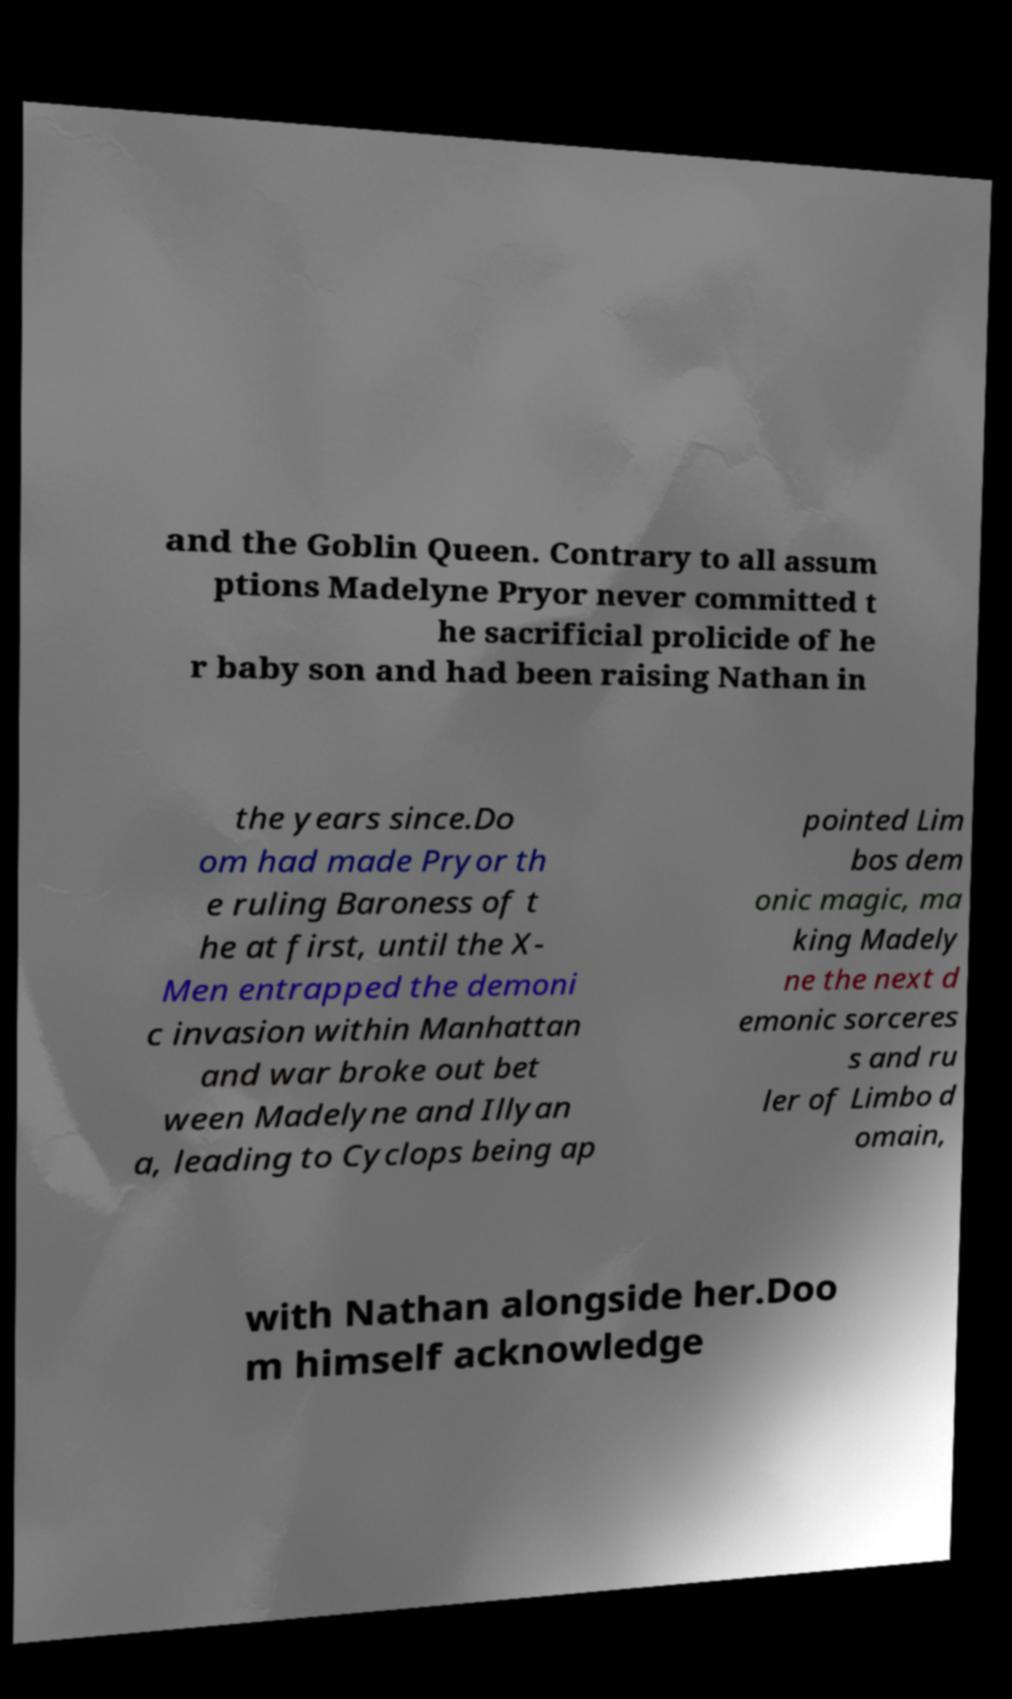Could you extract and type out the text from this image? and the Goblin Queen. Contrary to all assum ptions Madelyne Pryor never committed t he sacrificial prolicide of he r baby son and had been raising Nathan in the years since.Do om had made Pryor th e ruling Baroness of t he at first, until the X- Men entrapped the demoni c invasion within Manhattan and war broke out bet ween Madelyne and Illyan a, leading to Cyclops being ap pointed Lim bos dem onic magic, ma king Madely ne the next d emonic sorceres s and ru ler of Limbo d omain, with Nathan alongside her.Doo m himself acknowledge 